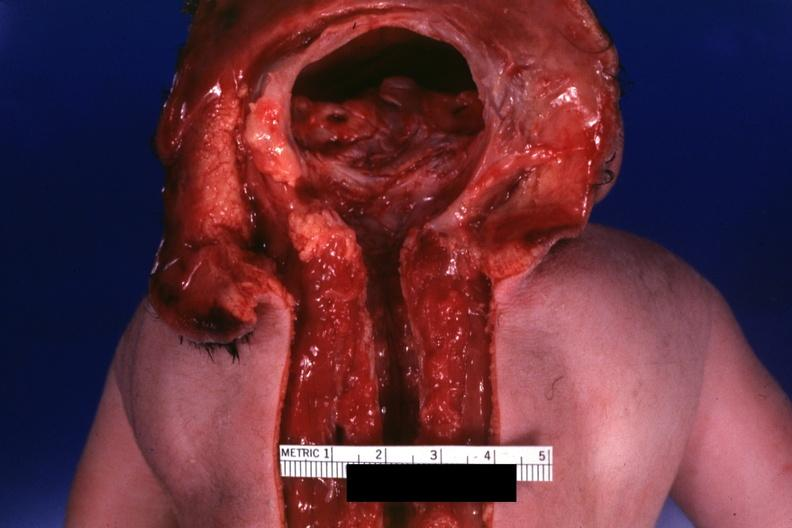s no chromosomal defects lived one day?
Answer the question using a single word or phrase. Yes 